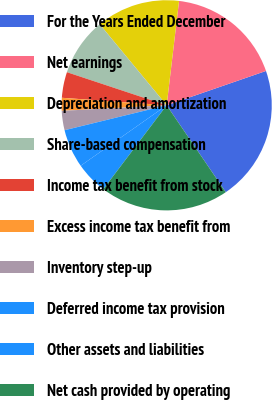<chart> <loc_0><loc_0><loc_500><loc_500><pie_chart><fcel>For the Years Ended December<fcel>Net earnings<fcel>Depreciation and amortization<fcel>Share-based compensation<fcel>Income tax benefit from stock<fcel>Excess income tax benefit from<fcel>Inventory step-up<fcel>Deferred income tax provision<fcel>Other assets and liabilities<fcel>Net cash provided by operating<nl><fcel>20.79%<fcel>17.82%<fcel>12.87%<fcel>8.91%<fcel>3.96%<fcel>1.98%<fcel>2.97%<fcel>5.94%<fcel>4.95%<fcel>19.8%<nl></chart> 